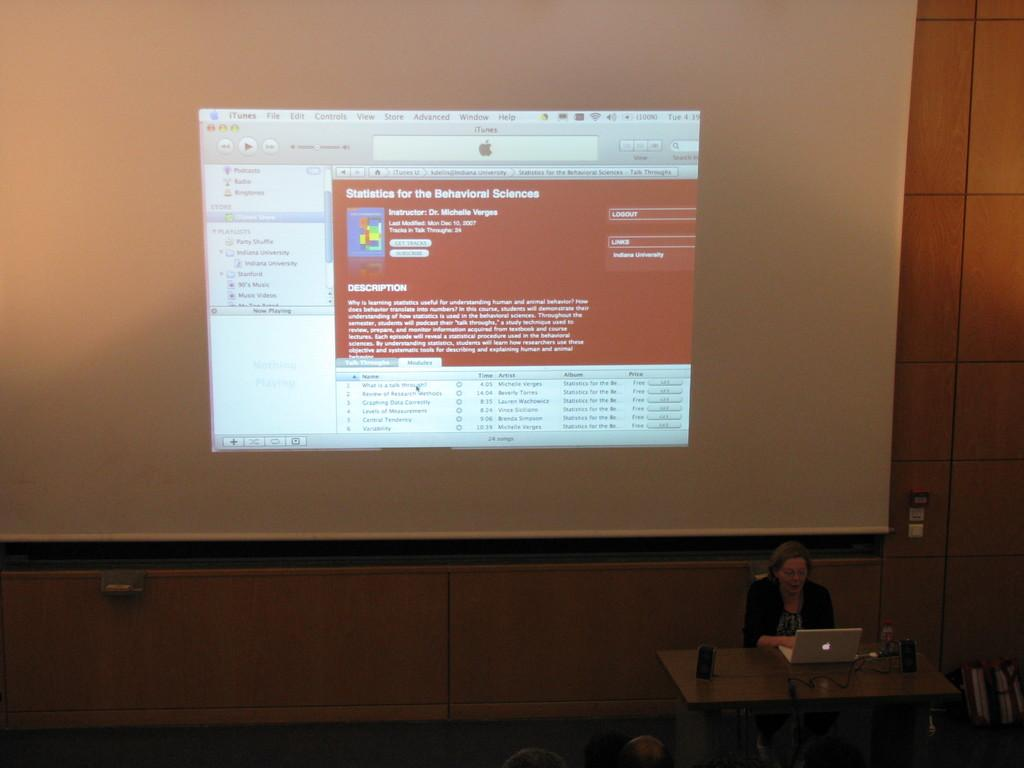Provide a one-sentence caption for the provided image. a screen with a webpage about statistics for the behavioral sciences. 